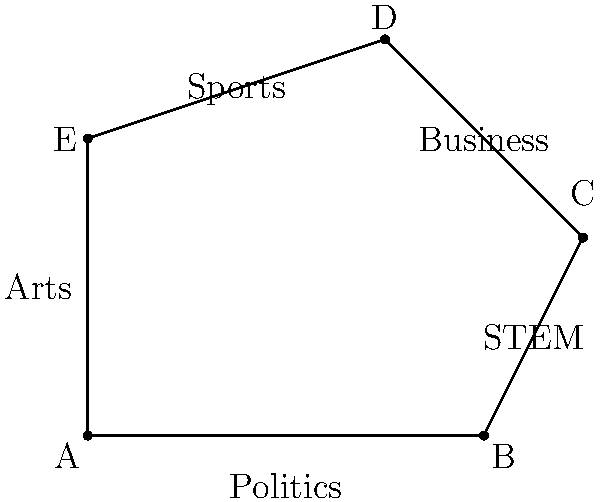The irregular pentagon ABCDE represents barriers broken by women in various professional fields. If AB = 4 units, BC = 2.24 units, CD = 2.83 units, DE = 3.16 units, and AE = 3 units, calculate the total perimeter of the polygon. What does this perimeter symbolize in the context of women's achievements? To calculate the perimeter of the irregular pentagon ABCDE, we need to sum up the lengths of all sides:

1. AB = 4 units (given)
2. BC = 2.24 units (given)
3. CD = 2.83 units (given)
4. DE = 3.16 units (given)
5. AE = 3 units (given)

Total perimeter = AB + BC + CD + DE + AE
$$\text{Perimeter} = 4 + 2.24 + 2.83 + 3.16 + 3 = 15.23 \text{ units}$$

In the context of women's achievements, this perimeter symbolizes the cumulative progress made by women in breaking barriers across various professional fields. Each side of the pentagon represents a different area where women have made significant strides:

- AB (Politics): Representing women's increasing participation and leadership in government and policy-making.
- BC (STEM): Symbolizing women's growing presence and contributions in Science, Technology, Engineering, and Mathematics.
- CD (Business): Illustrating women's advancement in corporate leadership and entrepreneurship.
- DE (Sports): Representing women's achievements and recognition in athletics and competitive sports.
- AE (Arts): Symbolizing women's contributions and success in various artistic fields.

The total perimeter of 15.23 units represents the collective impact of these achievements, emphasizing the interconnected nature of progress across different sectors and the overall advancement of women's rights and opportunities.
Answer: 15.23 units; symbolizes cumulative progress in breaking barriers across professional fields 